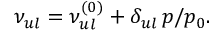Convert formula to latex. <formula><loc_0><loc_0><loc_500><loc_500>\nu _ { u l } = \nu _ { u l } ^ { ( 0 ) } + \delta _ { u l } \, p / p _ { 0 } .</formula> 